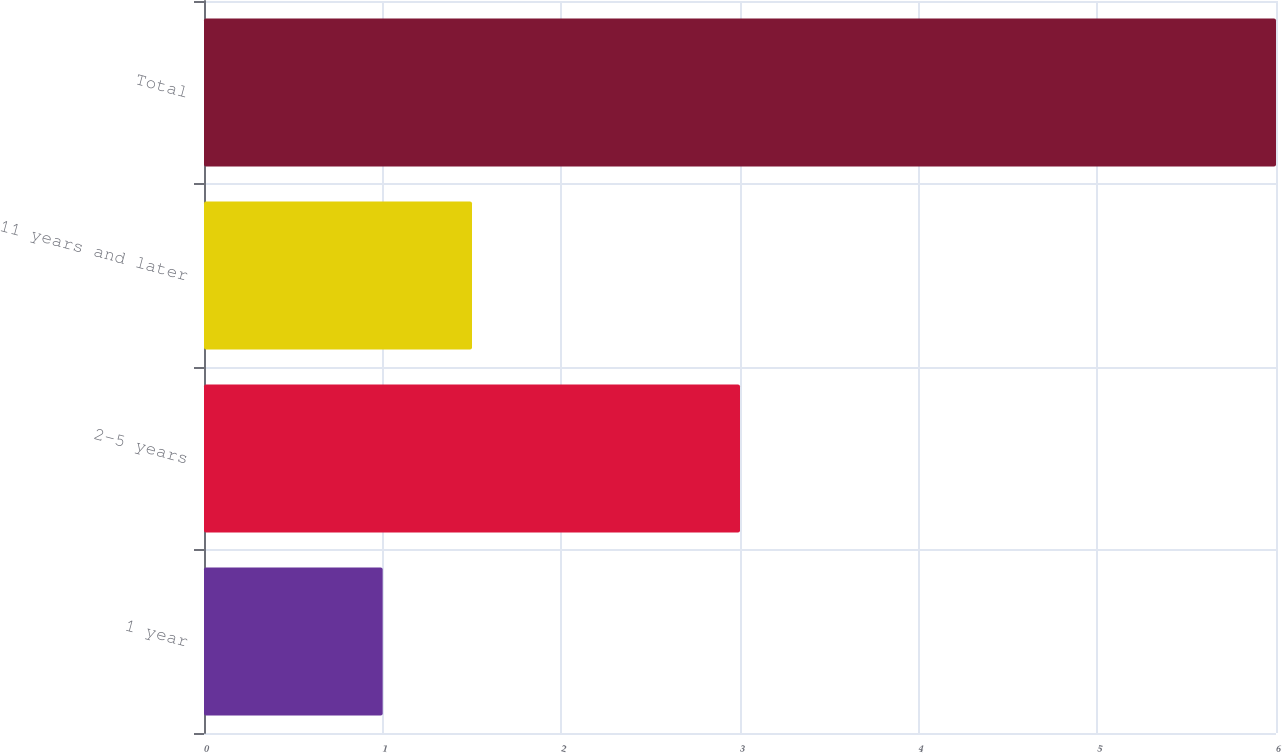<chart> <loc_0><loc_0><loc_500><loc_500><bar_chart><fcel>1 year<fcel>2-5 years<fcel>11 years and later<fcel>Total<nl><fcel>1<fcel>3<fcel>1.5<fcel>6<nl></chart> 